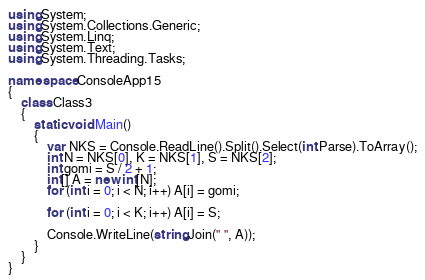Convert code to text. <code><loc_0><loc_0><loc_500><loc_500><_C#_>using System;
using System.Collections.Generic;
using System.Linq;
using System.Text;
using System.Threading.Tasks;

namespace ConsoleApp15
{
    class Class3
    {
        static void Main()
        {
            var NKS = Console.ReadLine().Split().Select(int.Parse).ToArray();
            int N = NKS[0], K = NKS[1], S = NKS[2];
            int gomi = S / 2 + 1;
            int[] A = new int[N];
            for (int i = 0; i < N; i++) A[i] = gomi;

            for (int i = 0; i < K; i++) A[i] = S;

            Console.WriteLine(string.Join(" ", A));
        }
    }
}
</code> 